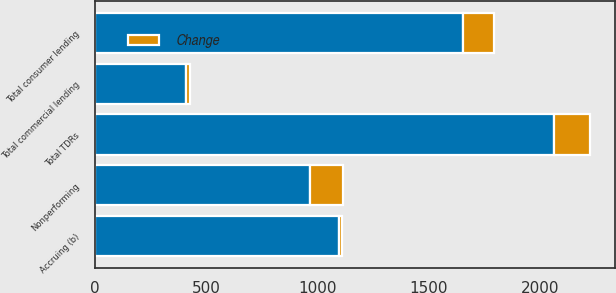Convert chart. <chart><loc_0><loc_0><loc_500><loc_500><stacked_bar_chart><ecel><fcel>Total commercial lending<fcel>Total consumer lending<fcel>Total TDRs<fcel>Nonperforming<fcel>Accruing (b)<nl><fcel>nan<fcel>409<fcel>1652<fcel>2061<fcel>964<fcel>1097<nl><fcel>Change<fcel>19<fcel>141<fcel>160<fcel>148<fcel>12<nl></chart> 